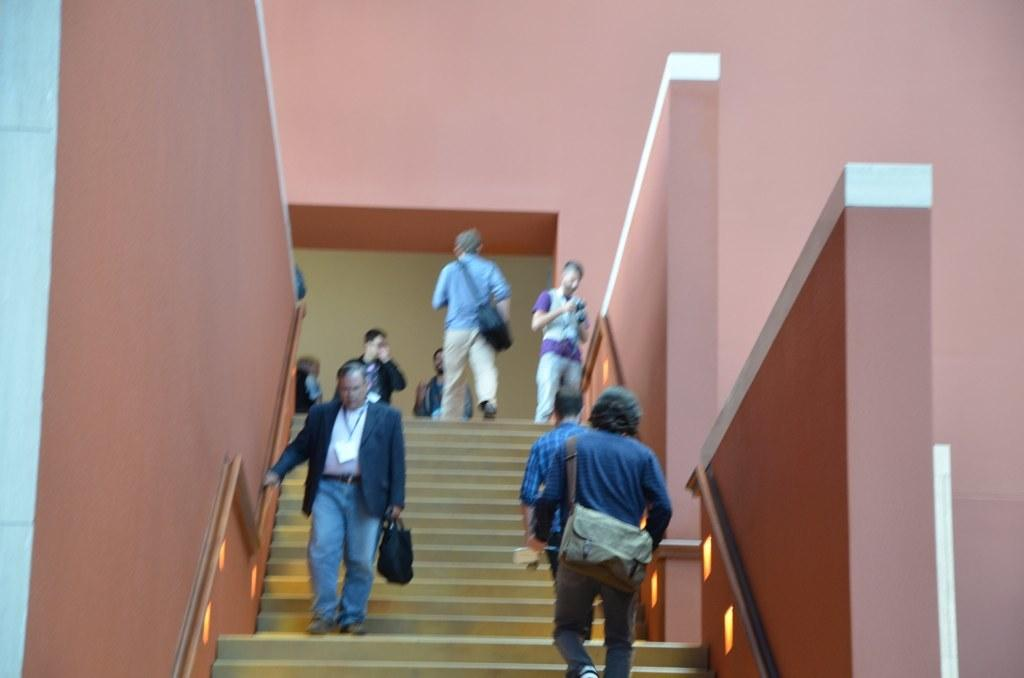What is the main subject of the image? The main subject of the image is a set of stairs. What are the people in the image doing? The people in the image are climbing the stairs. What can be seen in the background of the image? There is a wall in the background of the image. What is the distance between the boundary and the aftermath in the image? There is no boundary or aftermath present in the image; it features a set of stairs with people climbing them and a wall in the background. 